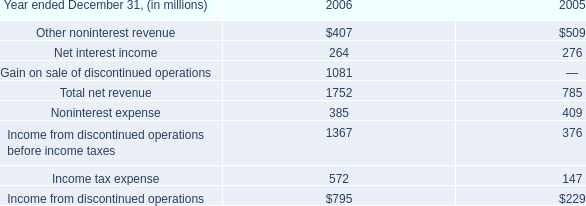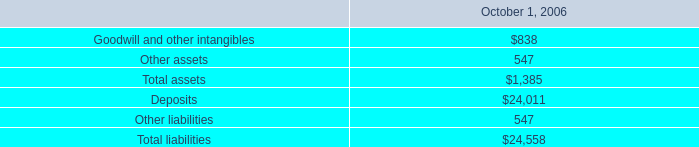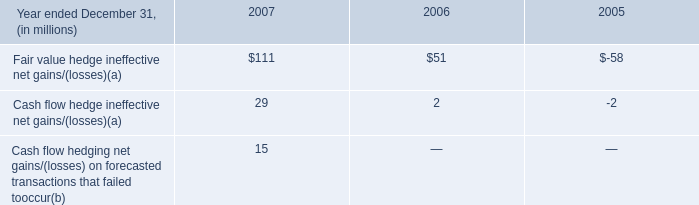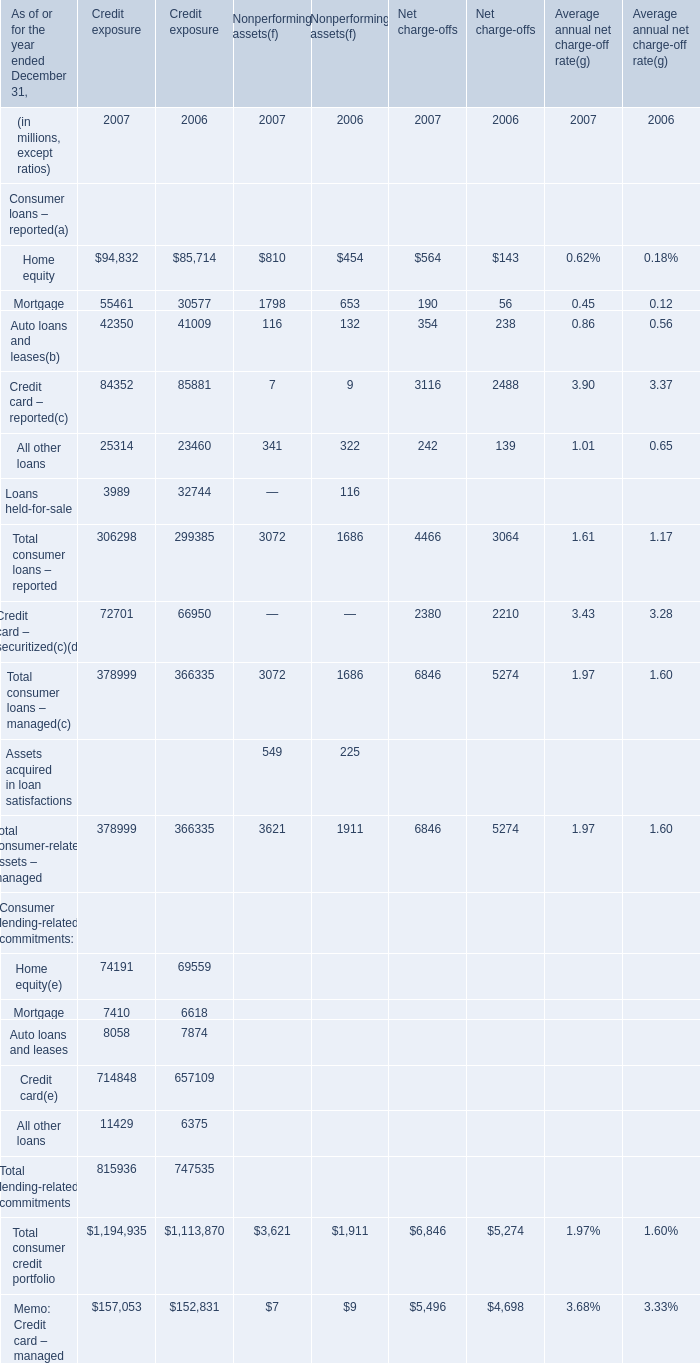What's the average of Income from discontinued operations before income taxes of 2006, and Home equity of Credit exposure 2006 ? 
Computations: ((1367.0 + 85714.0) / 2)
Answer: 43540.5. 